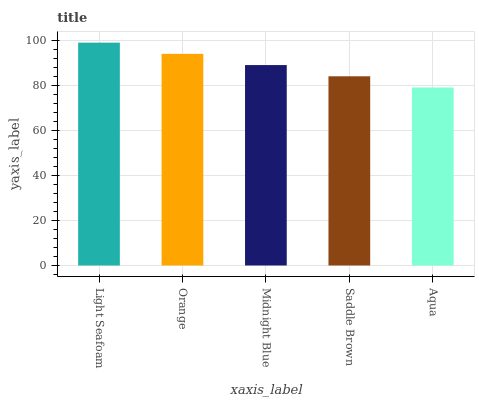Is Aqua the minimum?
Answer yes or no. Yes. Is Light Seafoam the maximum?
Answer yes or no. Yes. Is Orange the minimum?
Answer yes or no. No. Is Orange the maximum?
Answer yes or no. No. Is Light Seafoam greater than Orange?
Answer yes or no. Yes. Is Orange less than Light Seafoam?
Answer yes or no. Yes. Is Orange greater than Light Seafoam?
Answer yes or no. No. Is Light Seafoam less than Orange?
Answer yes or no. No. Is Midnight Blue the high median?
Answer yes or no. Yes. Is Midnight Blue the low median?
Answer yes or no. Yes. Is Aqua the high median?
Answer yes or no. No. Is Saddle Brown the low median?
Answer yes or no. No. 